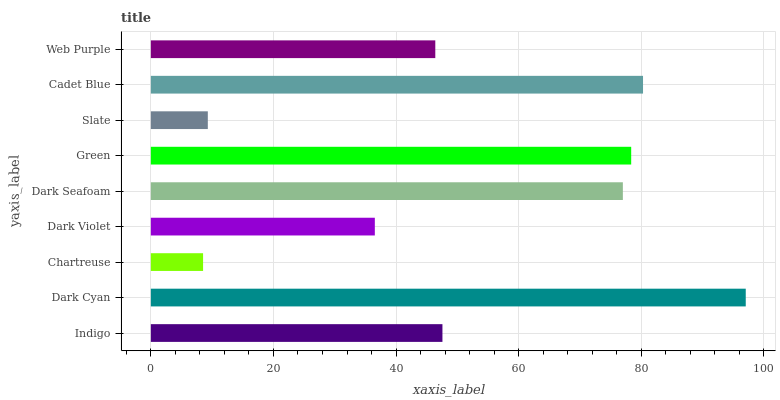Is Chartreuse the minimum?
Answer yes or no. Yes. Is Dark Cyan the maximum?
Answer yes or no. Yes. Is Dark Cyan the minimum?
Answer yes or no. No. Is Chartreuse the maximum?
Answer yes or no. No. Is Dark Cyan greater than Chartreuse?
Answer yes or no. Yes. Is Chartreuse less than Dark Cyan?
Answer yes or no. Yes. Is Chartreuse greater than Dark Cyan?
Answer yes or no. No. Is Dark Cyan less than Chartreuse?
Answer yes or no. No. Is Indigo the high median?
Answer yes or no. Yes. Is Indigo the low median?
Answer yes or no. Yes. Is Dark Seafoam the high median?
Answer yes or no. No. Is Cadet Blue the low median?
Answer yes or no. No. 